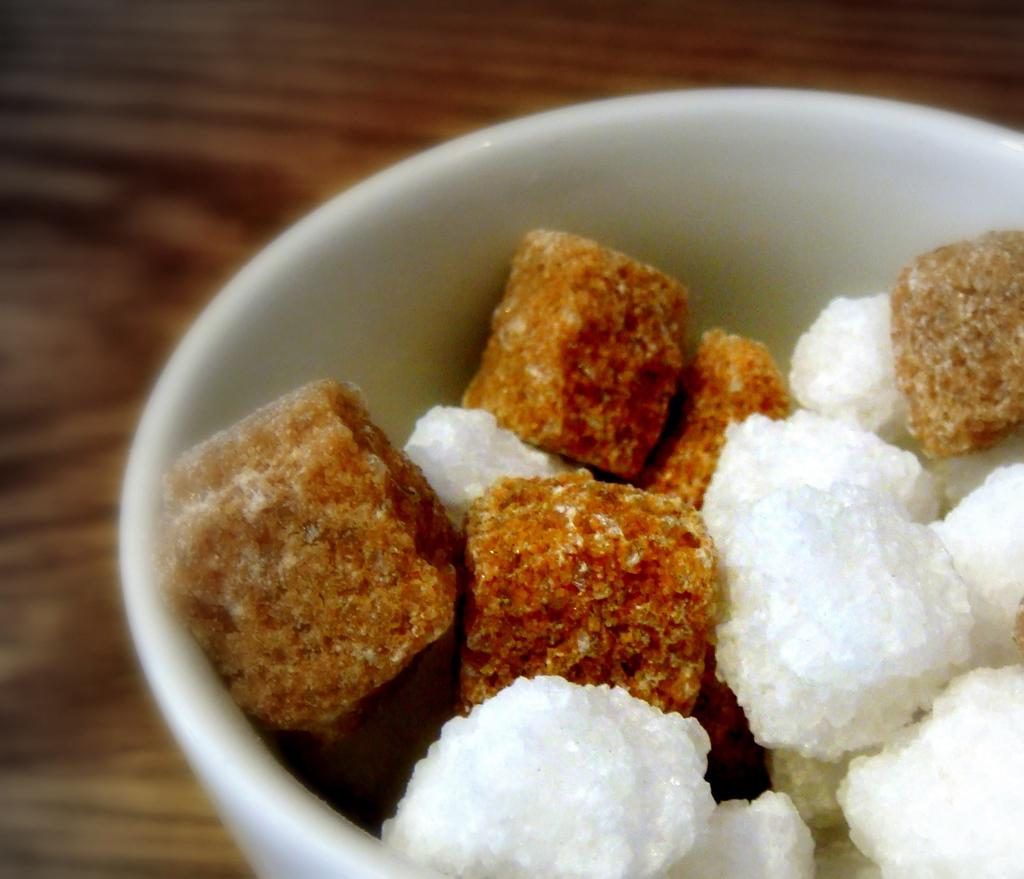What is the main subject in the image? There is a food item in a bowl in the image. Can you describe the background of the image? The background of the image is brown. What type of toy is visible in the image? There is no toy present in the image. Is there a cap being worn by the food item in the image? The food item in the image is not a person or animate object, so it cannot wear a cap. 